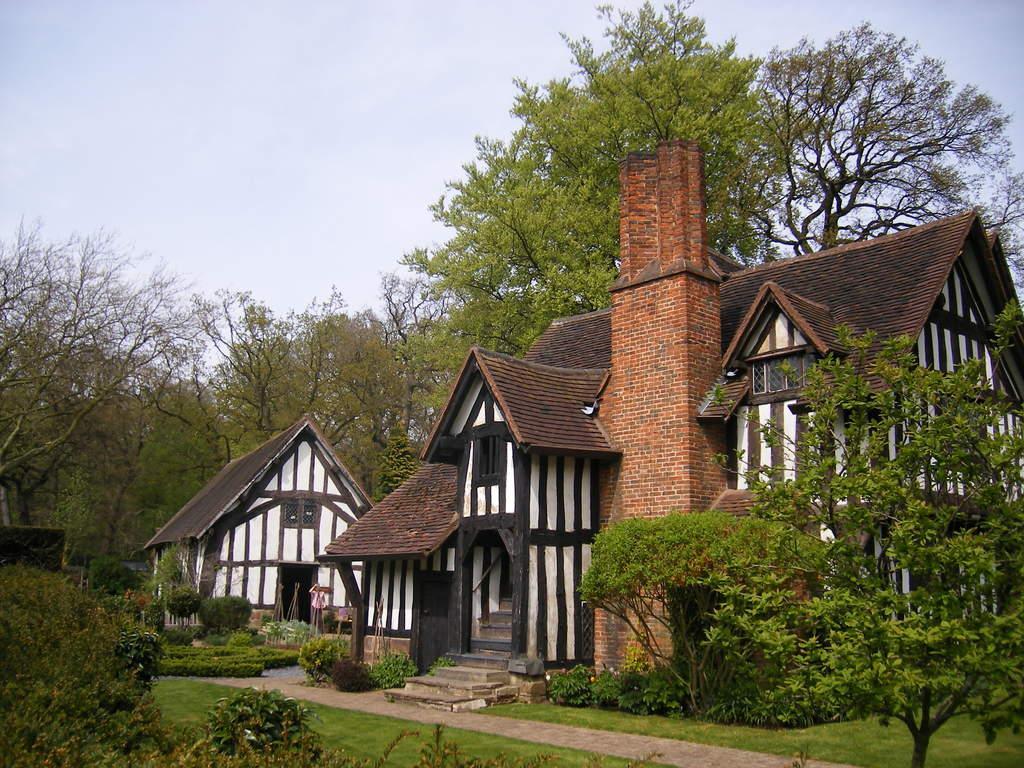Could you give a brief overview of what you see in this image? In the middle of the picture there are trees, house, person, plants and grass. At the top there is sky. At the bottom there are plants, grass and path. 